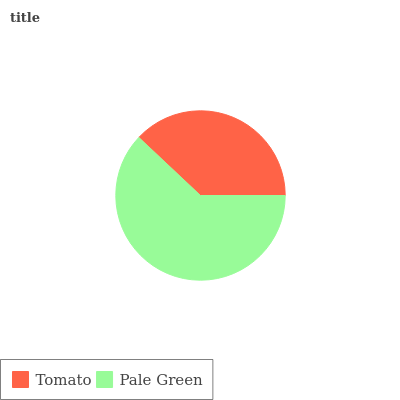Is Tomato the minimum?
Answer yes or no. Yes. Is Pale Green the maximum?
Answer yes or no. Yes. Is Pale Green the minimum?
Answer yes or no. No. Is Pale Green greater than Tomato?
Answer yes or no. Yes. Is Tomato less than Pale Green?
Answer yes or no. Yes. Is Tomato greater than Pale Green?
Answer yes or no. No. Is Pale Green less than Tomato?
Answer yes or no. No. Is Pale Green the high median?
Answer yes or no. Yes. Is Tomato the low median?
Answer yes or no. Yes. Is Tomato the high median?
Answer yes or no. No. Is Pale Green the low median?
Answer yes or no. No. 